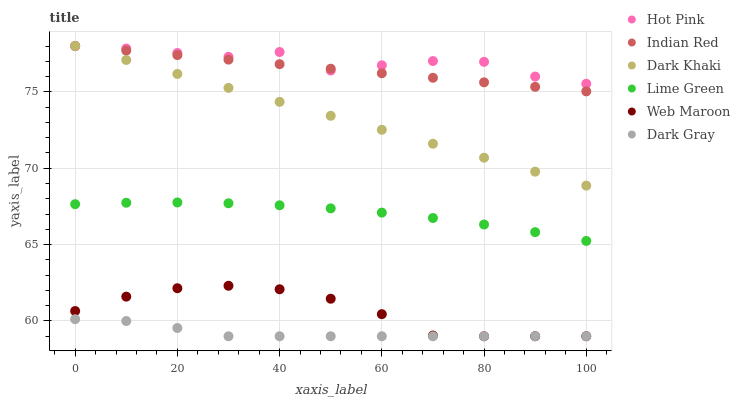Does Dark Gray have the minimum area under the curve?
Answer yes or no. Yes. Does Hot Pink have the maximum area under the curve?
Answer yes or no. Yes. Does Web Maroon have the minimum area under the curve?
Answer yes or no. No. Does Web Maroon have the maximum area under the curve?
Answer yes or no. No. Is Dark Khaki the smoothest?
Answer yes or no. Yes. Is Hot Pink the roughest?
Answer yes or no. Yes. Is Web Maroon the smoothest?
Answer yes or no. No. Is Web Maroon the roughest?
Answer yes or no. No. Does Dark Gray have the lowest value?
Answer yes or no. Yes. Does Hot Pink have the lowest value?
Answer yes or no. No. Does Indian Red have the highest value?
Answer yes or no. Yes. Does Web Maroon have the highest value?
Answer yes or no. No. Is Web Maroon less than Indian Red?
Answer yes or no. Yes. Is Hot Pink greater than Dark Gray?
Answer yes or no. Yes. Does Dark Khaki intersect Indian Red?
Answer yes or no. Yes. Is Dark Khaki less than Indian Red?
Answer yes or no. No. Is Dark Khaki greater than Indian Red?
Answer yes or no. No. Does Web Maroon intersect Indian Red?
Answer yes or no. No. 